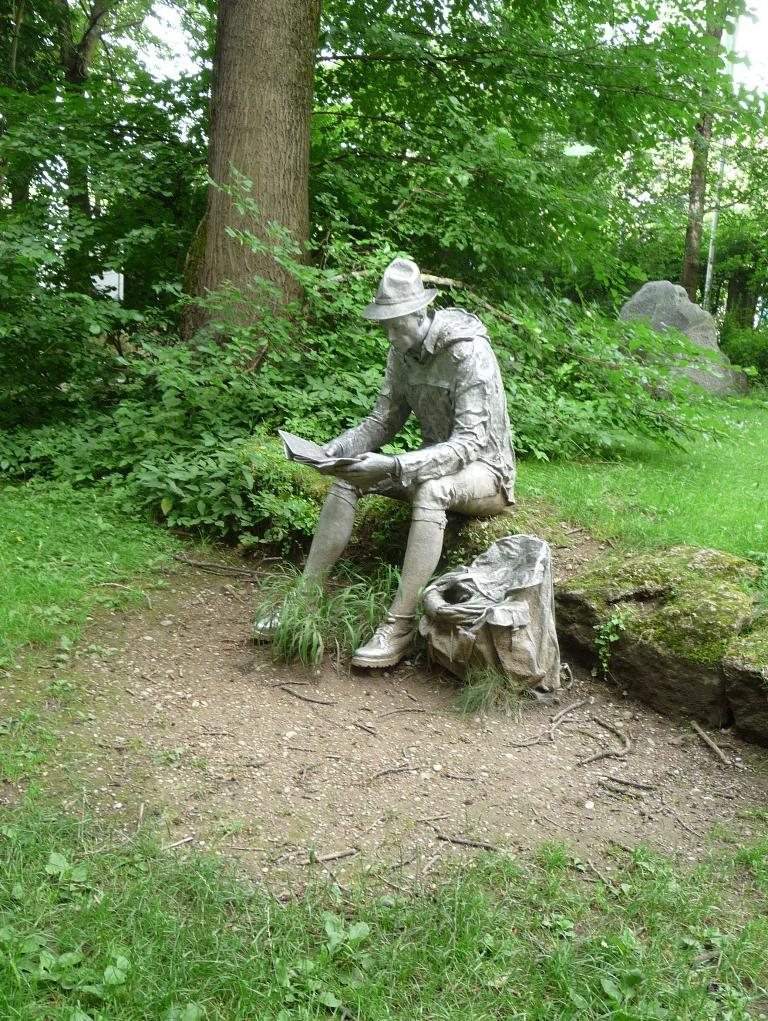What is the main subject of the image? There is a statue of a person sitting in the image. What is the statue holding? The statue is holding a book. What type of vegetation can be seen in the image? There are trees at the back of the image. What material is the stone in the image made of? The stone in the image is made of stone. What is visible at the top of the image? The sky is visible at the top of the image. What type of ground is present in the image? There is grass at the bottom of the image. How much debt does the statue owe to the stick in the image? There is no stick or debt present in the image; it features a statue holding a book. What type of learning is the statue engaged in while sitting on the stone? There is no indication of the statue learning or engaging in any activity in the image. 